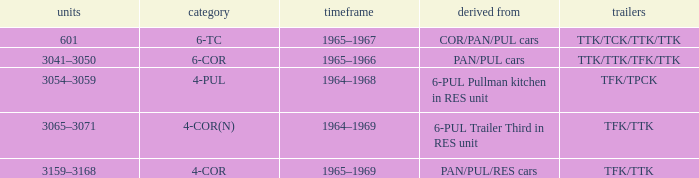Name the trailers for formed from pan/pul/res cars TFK/TTK. 